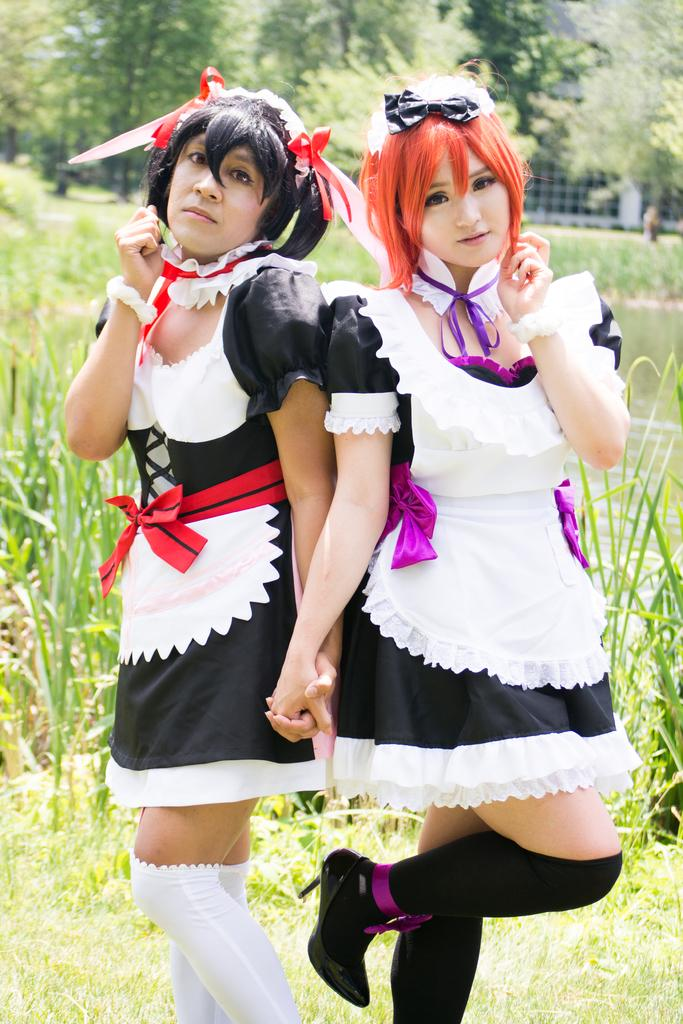How many girls are in the image? There are two girls standing in the image. What are the girls wearing? The girls are wearing clothes and shoes. What type of natural environment can be seen in the image? There is grass, grass plants, water, and trees visible in the image. How would you describe the background of the image? The background of the image is slightly blurred. What type of cable can be seen connecting the girls in the image? There is no cable visible in the image; it only shows two girls standing in a natural environment. 